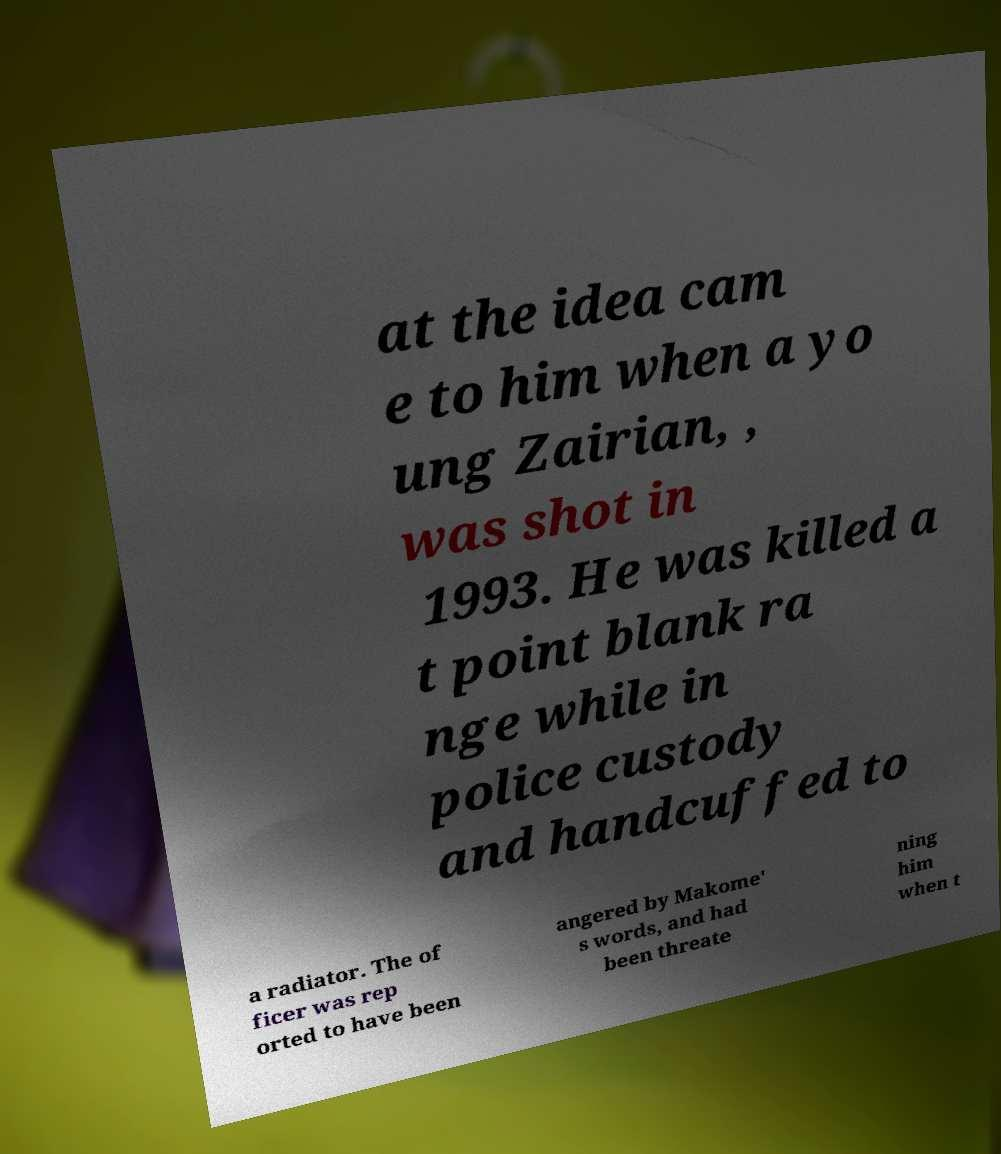Please identify and transcribe the text found in this image. at the idea cam e to him when a yo ung Zairian, , was shot in 1993. He was killed a t point blank ra nge while in police custody and handcuffed to a radiator. The of ficer was rep orted to have been angered by Makome' s words, and had been threate ning him when t 